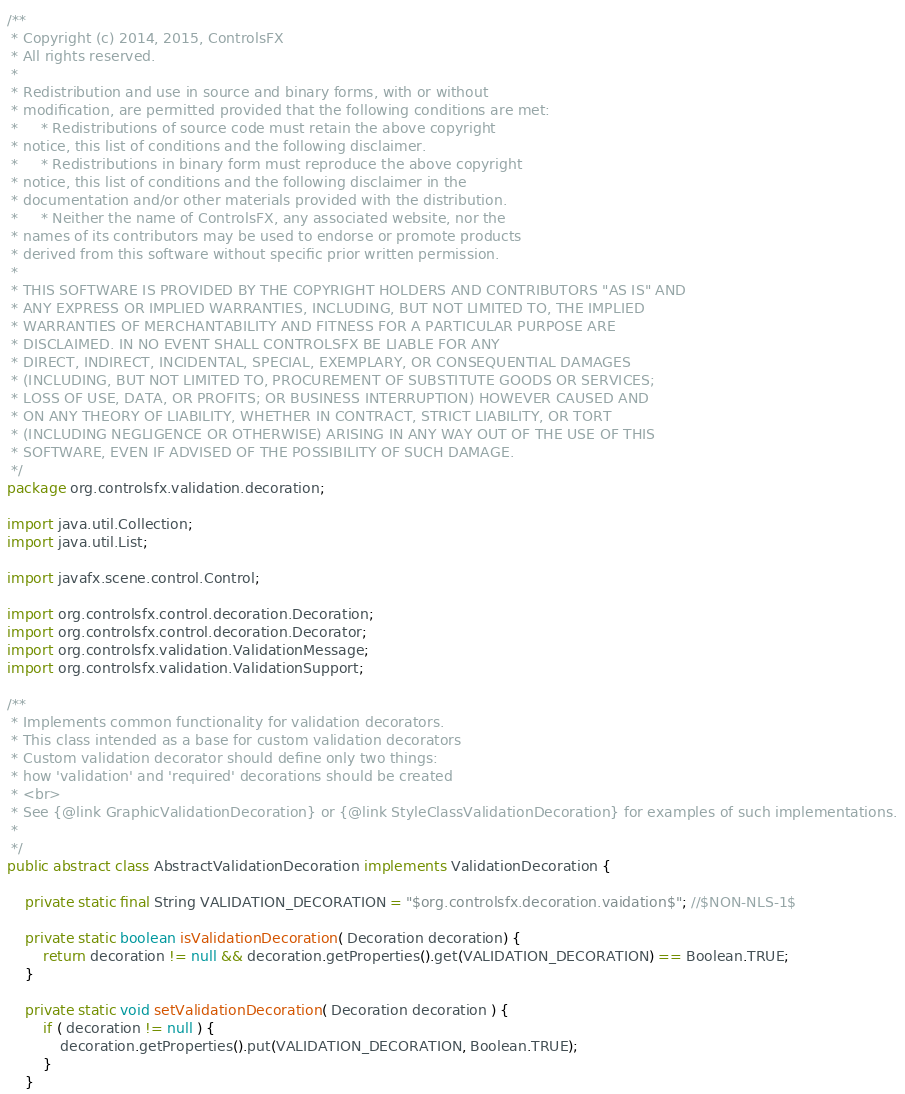<code> <loc_0><loc_0><loc_500><loc_500><_Java_>/**
 * Copyright (c) 2014, 2015, ControlsFX
 * All rights reserved.
 *
 * Redistribution and use in source and binary forms, with or without
 * modification, are permitted provided that the following conditions are met:
 *     * Redistributions of source code must retain the above copyright
 * notice, this list of conditions and the following disclaimer.
 *     * Redistributions in binary form must reproduce the above copyright
 * notice, this list of conditions and the following disclaimer in the
 * documentation and/or other materials provided with the distribution.
 *     * Neither the name of ControlsFX, any associated website, nor the
 * names of its contributors may be used to endorse or promote products
 * derived from this software without specific prior written permission.
 *
 * THIS SOFTWARE IS PROVIDED BY THE COPYRIGHT HOLDERS AND CONTRIBUTORS "AS IS" AND
 * ANY EXPRESS OR IMPLIED WARRANTIES, INCLUDING, BUT NOT LIMITED TO, THE IMPLIED
 * WARRANTIES OF MERCHANTABILITY AND FITNESS FOR A PARTICULAR PURPOSE ARE
 * DISCLAIMED. IN NO EVENT SHALL CONTROLSFX BE LIABLE FOR ANY
 * DIRECT, INDIRECT, INCIDENTAL, SPECIAL, EXEMPLARY, OR CONSEQUENTIAL DAMAGES
 * (INCLUDING, BUT NOT LIMITED TO, PROCUREMENT OF SUBSTITUTE GOODS OR SERVICES;
 * LOSS OF USE, DATA, OR PROFITS; OR BUSINESS INTERRUPTION) HOWEVER CAUSED AND
 * ON ANY THEORY OF LIABILITY, WHETHER IN CONTRACT, STRICT LIABILITY, OR TORT
 * (INCLUDING NEGLIGENCE OR OTHERWISE) ARISING IN ANY WAY OUT OF THE USE OF THIS
 * SOFTWARE, EVEN IF ADVISED OF THE POSSIBILITY OF SUCH DAMAGE.
 */
package org.controlsfx.validation.decoration;

import java.util.Collection;
import java.util.List;

import javafx.scene.control.Control;

import org.controlsfx.control.decoration.Decoration;
import org.controlsfx.control.decoration.Decorator;
import org.controlsfx.validation.ValidationMessage;
import org.controlsfx.validation.ValidationSupport;

/**
 * Implements common functionality for validation decorators.
 * This class intended as a base for custom validation decorators   
 * Custom validation decorator should define only two things:
 * how 'validation' and 'required' decorations should be created
 * <br>
 * See {@link GraphicValidationDecoration} or {@link StyleClassValidationDecoration} for examples of such implementations.
 * 
 */
public abstract class AbstractValidationDecoration implements ValidationDecoration {
	
	private static final String VALIDATION_DECORATION = "$org.controlsfx.decoration.vaidation$"; //$NON-NLS-1$
	
	private static boolean isValidationDecoration( Decoration decoration) {
        return decoration != null && decoration.getProperties().get(VALIDATION_DECORATION) == Boolean.TRUE;
    }

	private static void setValidationDecoration( Decoration decoration ) {
        if ( decoration != null ) {
            decoration.getProperties().put(VALIDATION_DECORATION, Boolean.TRUE);
        }
    }
</code> 